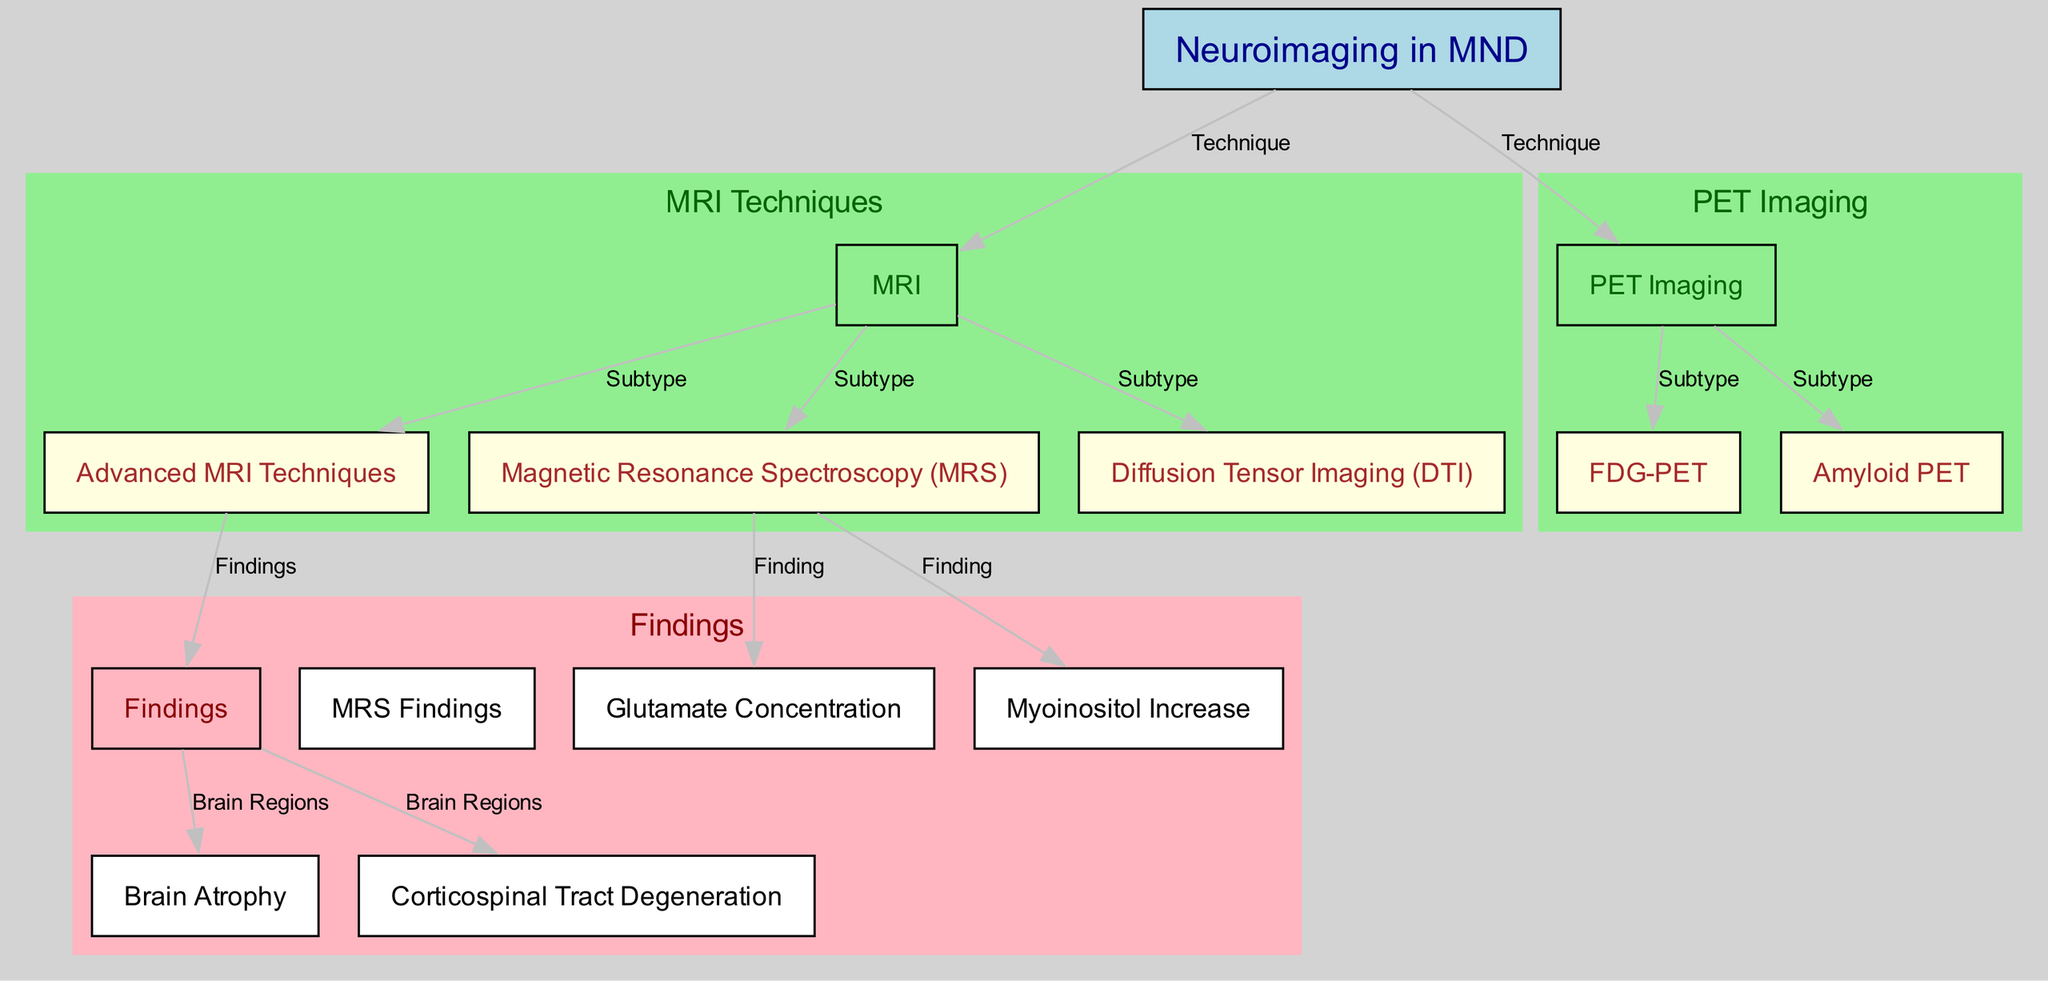What is the main focus of the diagram? The diagram centers on "Neuroimaging in MND," as indicated by the primary node labeled "Neuroimaging in MND." This node serves as the central theme of the diagram around which other techniques and findings are related.
Answer: Neuroimaging in MND How many imaging techniques are mentioned in the diagram? The diagram lists three imaging techniques: MRI, Magnetic Resonance Spectroscopy (MRS), and PET Imaging. Counting these nodes provides the answer to how many techniques are discussed.
Answer: Three What relationship links MRI to Brain Atrophy? The edges label "Findings" connects the node "MRI" to "Brain Atrophy," indicating that MRI is used to find or observe brain atrophy in patients with MND. This demonstrates the role of MRI in identifying this particular finding.
Answer: Findings What are the two subtypes of PET Imaging mentioned? The subtypes are "FDG-PET" and "Amyloid PET." These are two specific forms of PET imaging detailed in the diagram under the main PET Imaging node.
Answer: FDG-PET and Amyloid PET Which MRS finding indicates an increase in a particular substance? The diagram identifies "Myoinositol Increase" as a finding from Magnetic Resonance Spectroscopy (MRS). It specifies a particular change in concentration observed through this imaging technique in MND patients.
Answer: Myoinositol Increase What brain region is associated with Corticospinal Tract Degeneration? The diagram directly connects "Corticospinal Tract Degeneration" to the findings under "Findings." This implies that the degeneration occurs within brain regions associated with the corticospinal tract, although specific names are not cited.
Answer: Brain Regions Which advanced MRI technique is focused on fiber integrity? The node labeled "Diffusion Tensor Imaging (DTI)" is specifically associated with the assessment of white matter fiber integrity, making it distinct among the advanced MRI techniques presented in the diagram.
Answer: Diffusion Tensor Imaging (DTI) How does MRS contribute to understanding neurochemical changes in MND? By detailing findings such as glutamate concentration and myoinositol increase, MRS provides insights into neurochemical changes. The connections in the diagram point to how MRS is instrumental in identifying these specific findings that reflect the biochemical environment of the brain in MND.
Answer: MRS Findings 